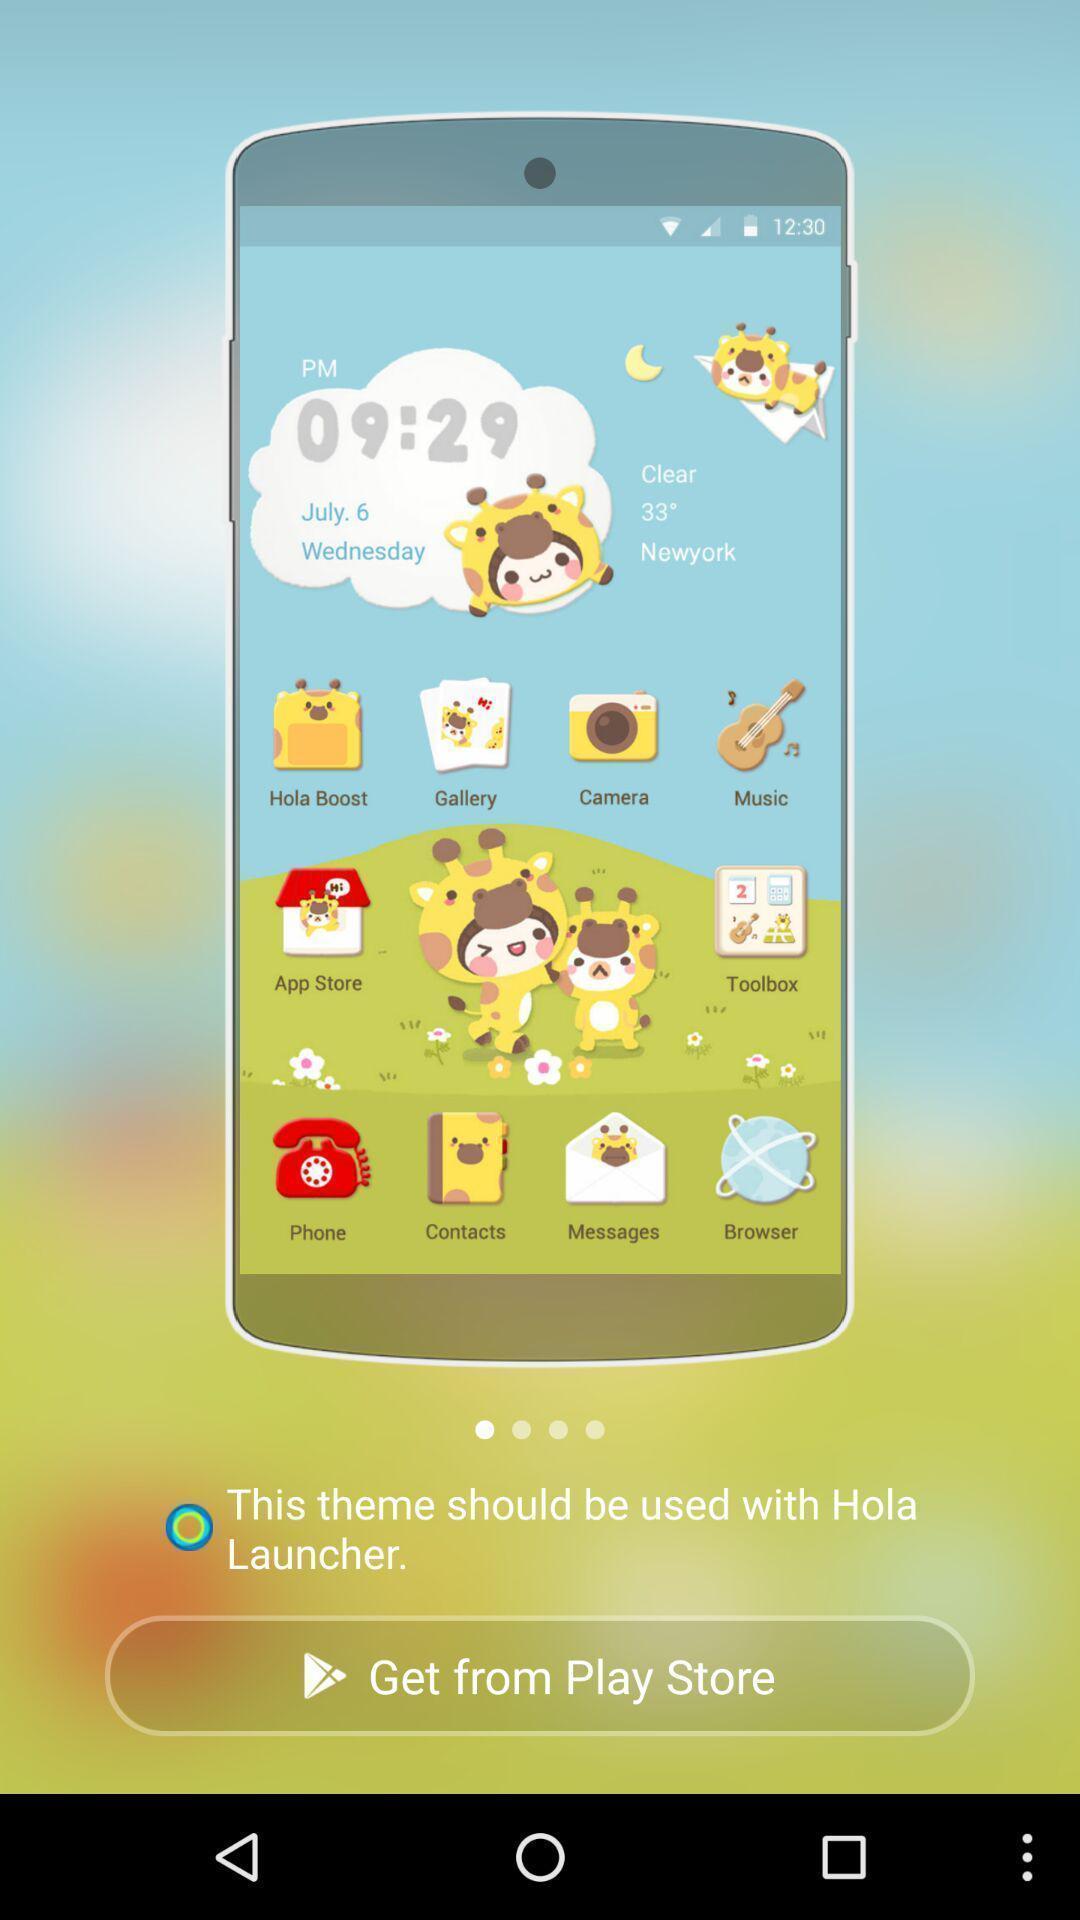Please provide a description for this image. Page displaying the themes to download. 